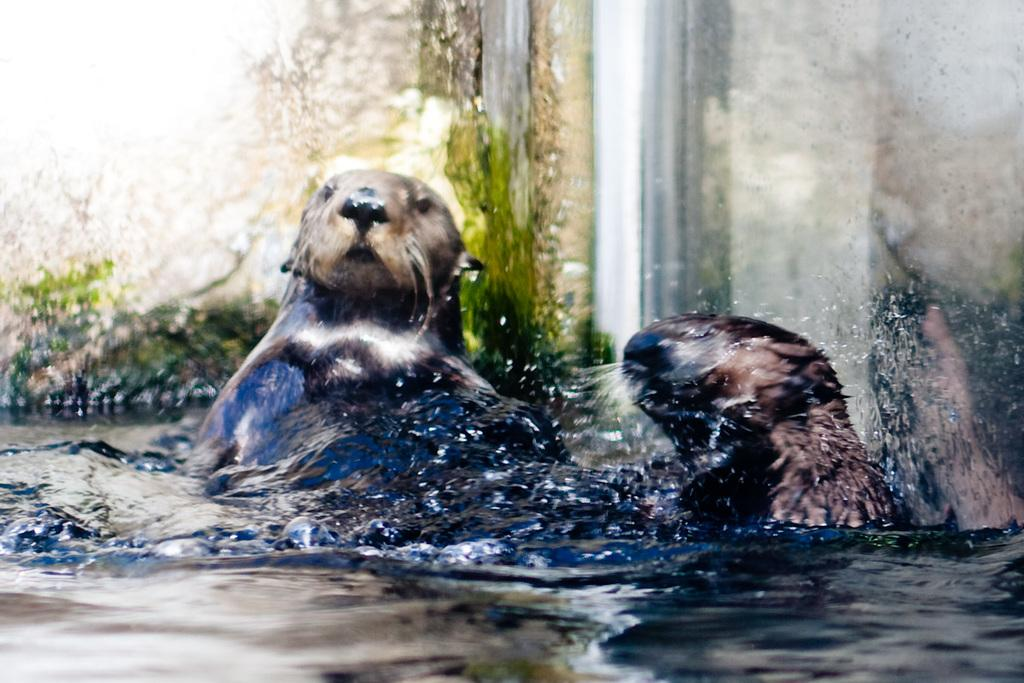What type of animals can be seen in the image? There are animals in the water. Can you describe the environment where the animals are located? The animals are in the water, which suggests a water-based environment. What might the animals be doing in the water? The animals could be swimming, feeding, or interacting with each other in the water. Are there any dinosaurs visible in the image? No, there are no dinosaurs present in the image. Is there a river visible in the image? The provided facts do not mention a river, so it cannot be determined from the image. 